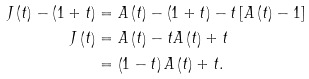Convert formula to latex. <formula><loc_0><loc_0><loc_500><loc_500>J \left ( t \right ) - \left ( 1 + t \right ) & = A \left ( t \right ) - \left ( 1 + t \right ) - t \left [ A \left ( t \right ) - 1 \right ] \\ J \left ( t \right ) & = A \left ( t \right ) - t A \left ( t \right ) + t \\ & = \left ( 1 - t \right ) A \left ( t \right ) + t .</formula> 